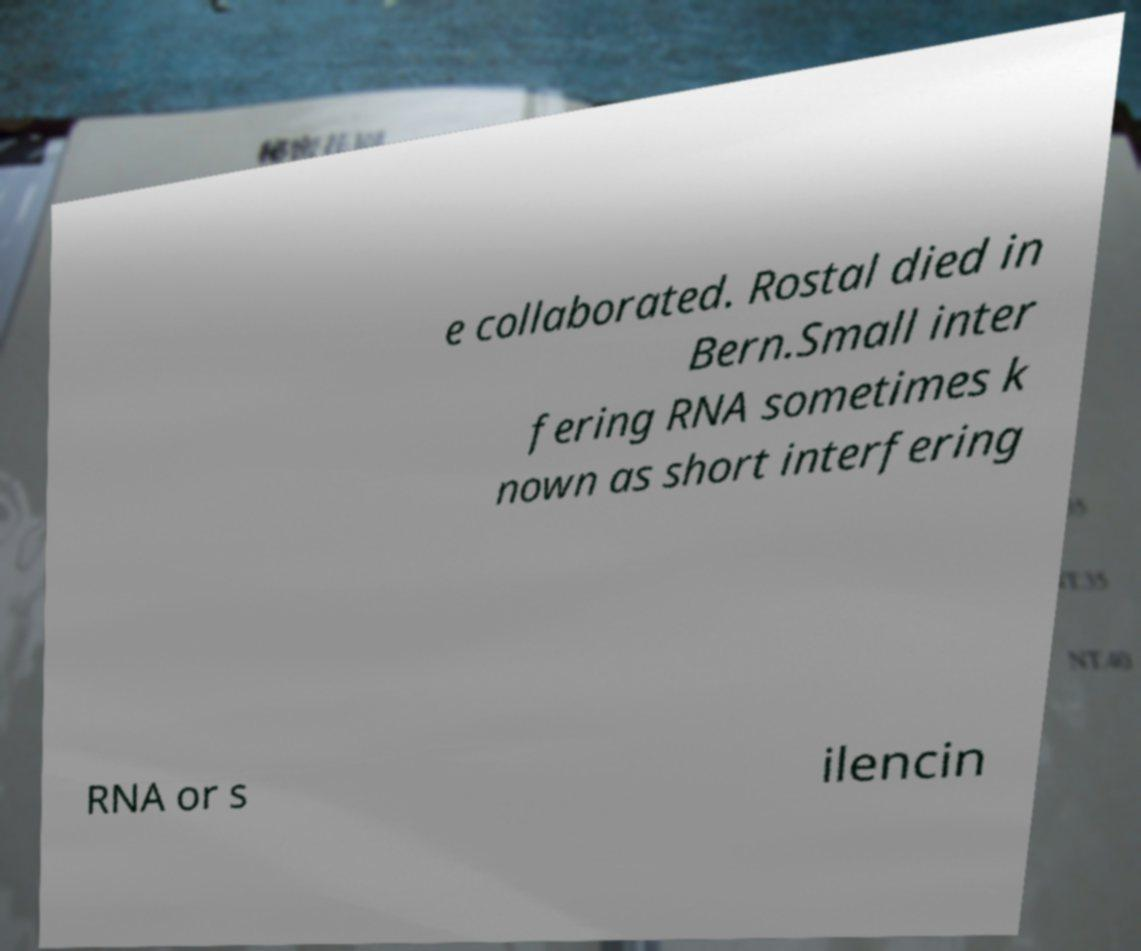Please read and relay the text visible in this image. What does it say? e collaborated. Rostal died in Bern.Small inter fering RNA sometimes k nown as short interfering RNA or s ilencin 